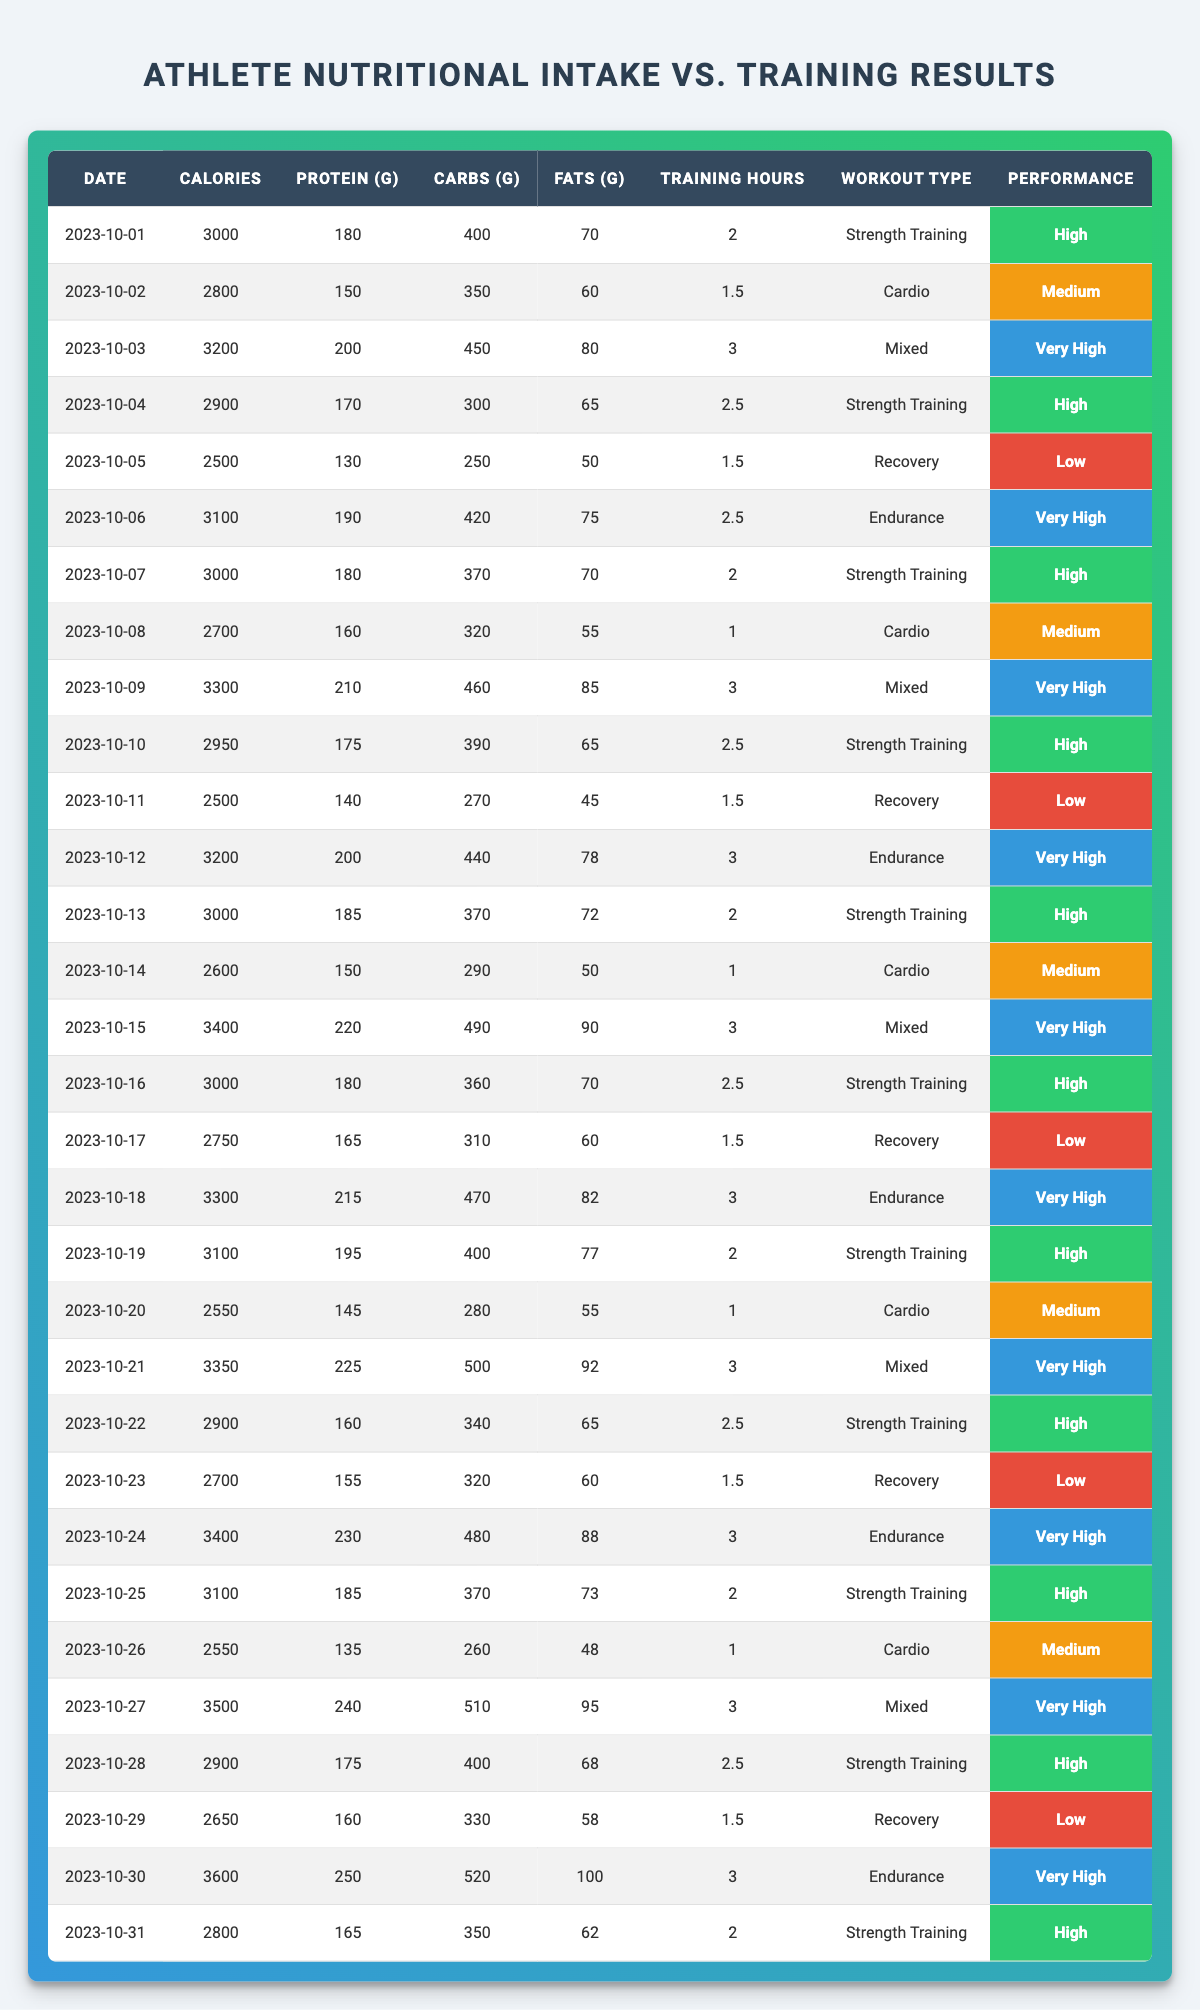What was the highest protein intake recorded during the month? The table shows that the highest protein intake was on 2023-10-27, where it recorded 240 grams.
Answer: 240 grams What is the total training hours for endurance workouts in October? By summing the training hours for endurance workouts, we have 2.5 (on 2023-10-06) + 3 (on 2023-10-12) + 3 (on 2023-10-18) + 3 (on 2023-10-30) = 11.5 hours.
Answer: 11.5 hours Did any day show a performance rating of "Low" while having over 2500 calories intake? Yes, on 2023-10-05 and 2023-10-11 both had a "Low" performance rating with 2500 calories intake.
Answer: Yes What is the average calorie intake for days with a performance rating of "Very High"? The dates with "Very High" performance ratings are 2023-10-03, 2023-10-06, 2023-10-12, 2023-10-09, 2023-10-15, 2023-10-18, 2023-10-21, 2023-10-24, 2023-10-27, and 2023-10-30. The calorie intakes on these days are 3200, 3100, 3200, 3300, 3400, 3300, 3350, 3400, 3500, and 3600. When summed up (3200 + 3100 + 3200 + 3300 + 3400 + 3300 + 3350 + 3400 + 3500 + 3600) = 33700, divided by 10 gives an average of 3370 calories per day.
Answer: 3370 calories How many days had "Strength Training" as the workout type? Counting the rows, there are 14 instances of "Strength Training" in the table, which can be confirmed by reviewing each entry.
Answer: 14 days Was the performance rating on 2023-10-16 equal to "High"? Yes, the table indicates that the performance rating on 2023-10-16 is labeled as "High".
Answer: Yes 